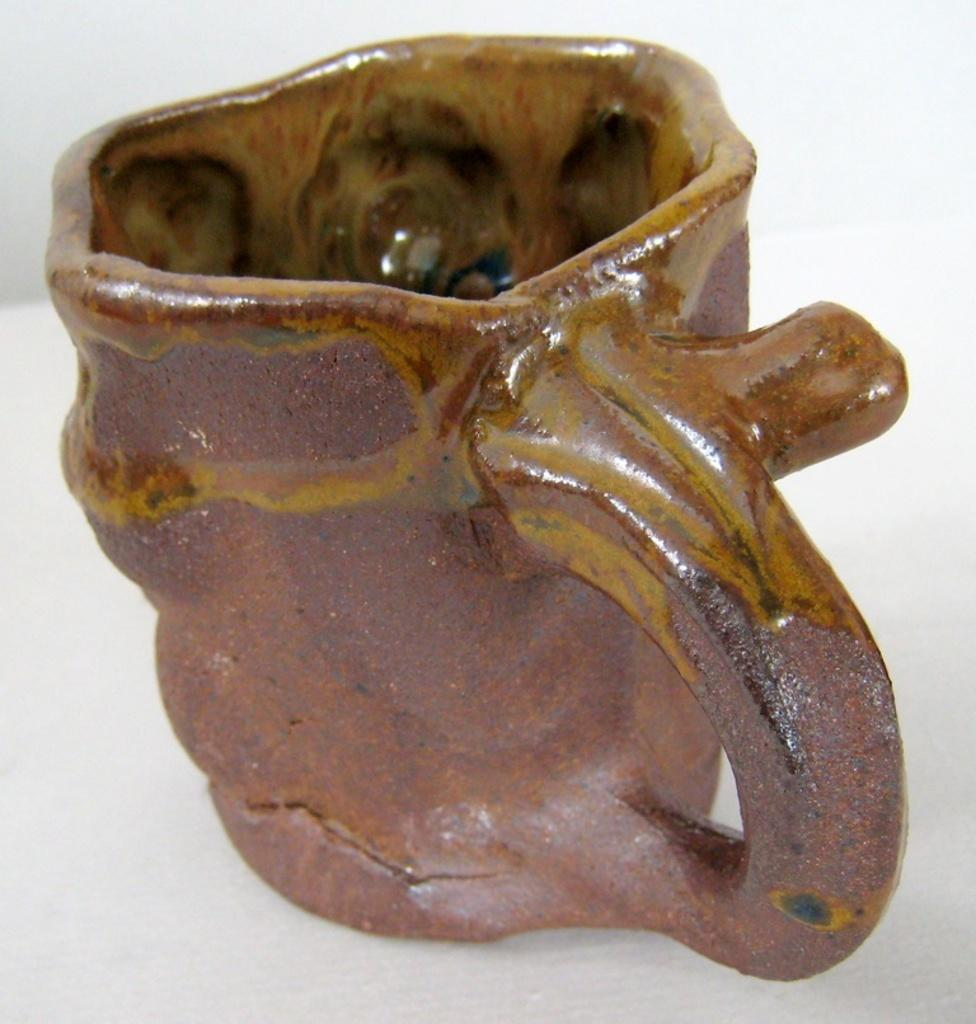What object can be seen in the image? There is a cup in the image. What color is the cup? The cup is brown in color. Where is the zipper located on the cup in the image? There is no zipper present on the cup in the image. What type of bed is visible in the image? There is no bed present in the image; it only features a brown cup. 